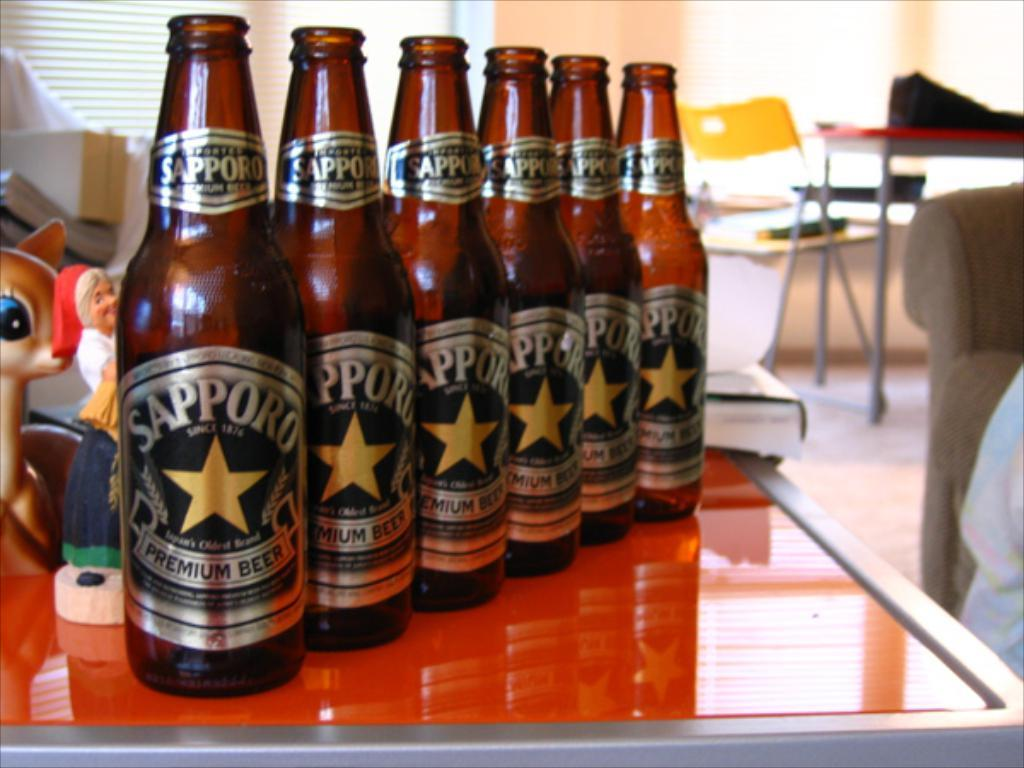<image>
Create a compact narrative representing the image presented. Bottles of Sapporo beer are lined up in a straight row. 